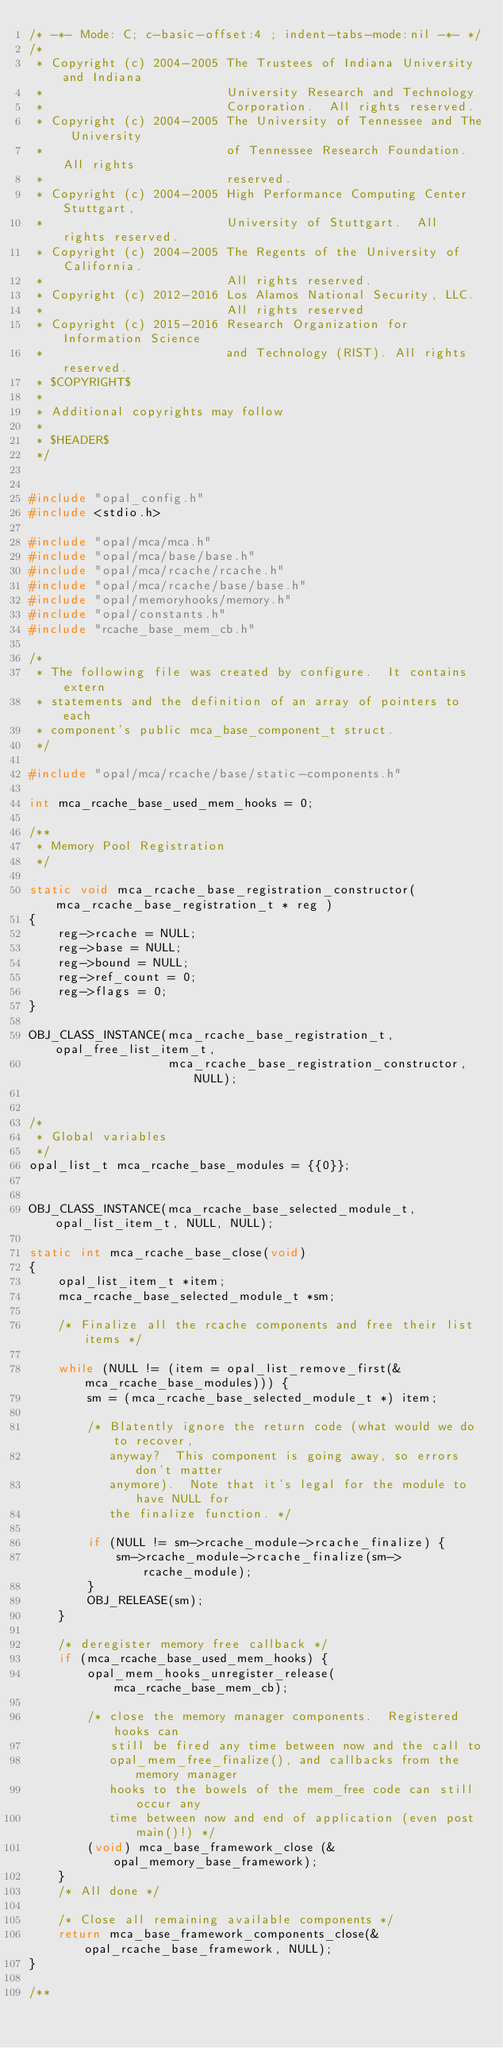<code> <loc_0><loc_0><loc_500><loc_500><_C_>/* -*- Mode: C; c-basic-offset:4 ; indent-tabs-mode:nil -*- */
/*
 * Copyright (c) 2004-2005 The Trustees of Indiana University and Indiana
 *                         University Research and Technology
 *                         Corporation.  All rights reserved.
 * Copyright (c) 2004-2005 The University of Tennessee and The University
 *                         of Tennessee Research Foundation.  All rights
 *                         reserved.
 * Copyright (c) 2004-2005 High Performance Computing Center Stuttgart,
 *                         University of Stuttgart.  All rights reserved.
 * Copyright (c) 2004-2005 The Regents of the University of California.
 *                         All rights reserved.
 * Copyright (c) 2012-2016 Los Alamos National Security, LLC.
 *                         All rights reserved
 * Copyright (c) 2015-2016 Research Organization for Information Science
 *                         and Technology (RIST). All rights reserved.
 * $COPYRIGHT$
 *
 * Additional copyrights may follow
 *
 * $HEADER$
 */


#include "opal_config.h"
#include <stdio.h>

#include "opal/mca/mca.h"
#include "opal/mca/base/base.h"
#include "opal/mca/rcache/rcache.h"
#include "opal/mca/rcache/base/base.h"
#include "opal/memoryhooks/memory.h"
#include "opal/constants.h"
#include "rcache_base_mem_cb.h"

/*
 * The following file was created by configure.  It contains extern
 * statements and the definition of an array of pointers to each
 * component's public mca_base_component_t struct.
 */

#include "opal/mca/rcache/base/static-components.h"

int mca_rcache_base_used_mem_hooks = 0;

/**
 * Memory Pool Registration
 */

static void mca_rcache_base_registration_constructor( mca_rcache_base_registration_t * reg )
{
    reg->rcache = NULL;
    reg->base = NULL;
    reg->bound = NULL;
    reg->ref_count = 0;
    reg->flags = 0;
}

OBJ_CLASS_INSTANCE(mca_rcache_base_registration_t, opal_free_list_item_t,
                   mca_rcache_base_registration_constructor, NULL);


/*
 * Global variables
 */
opal_list_t mca_rcache_base_modules = {{0}};


OBJ_CLASS_INSTANCE(mca_rcache_base_selected_module_t, opal_list_item_t, NULL, NULL);

static int mca_rcache_base_close(void)
{
    opal_list_item_t *item;
    mca_rcache_base_selected_module_t *sm;

    /* Finalize all the rcache components and free their list items */

    while (NULL != (item = opal_list_remove_first(&mca_rcache_base_modules))) {
        sm = (mca_rcache_base_selected_module_t *) item;

        /* Blatently ignore the return code (what would we do to recover,
           anyway?  This component is going away, so errors don't matter
           anymore).  Note that it's legal for the module to have NULL for
           the finalize function. */

        if (NULL != sm->rcache_module->rcache_finalize) {
            sm->rcache_module->rcache_finalize(sm->rcache_module);
        }
        OBJ_RELEASE(sm);
    }

    /* deregister memory free callback */
    if (mca_rcache_base_used_mem_hooks) {
        opal_mem_hooks_unregister_release(mca_rcache_base_mem_cb);

        /* close the memory manager components.  Registered hooks can
           still be fired any time between now and the call to
           opal_mem_free_finalize(), and callbacks from the memory manager
           hooks to the bowels of the mem_free code can still occur any
           time between now and end of application (even post main()!) */
        (void) mca_base_framework_close (&opal_memory_base_framework);
    }
    /* All done */

    /* Close all remaining available components */
    return mca_base_framework_components_close(&opal_rcache_base_framework, NULL);
}

/**</code> 